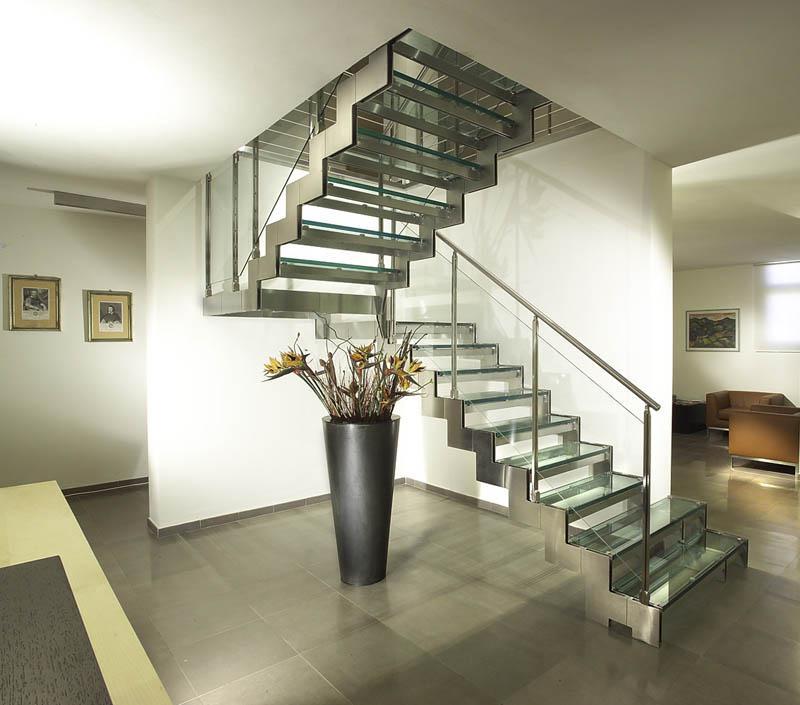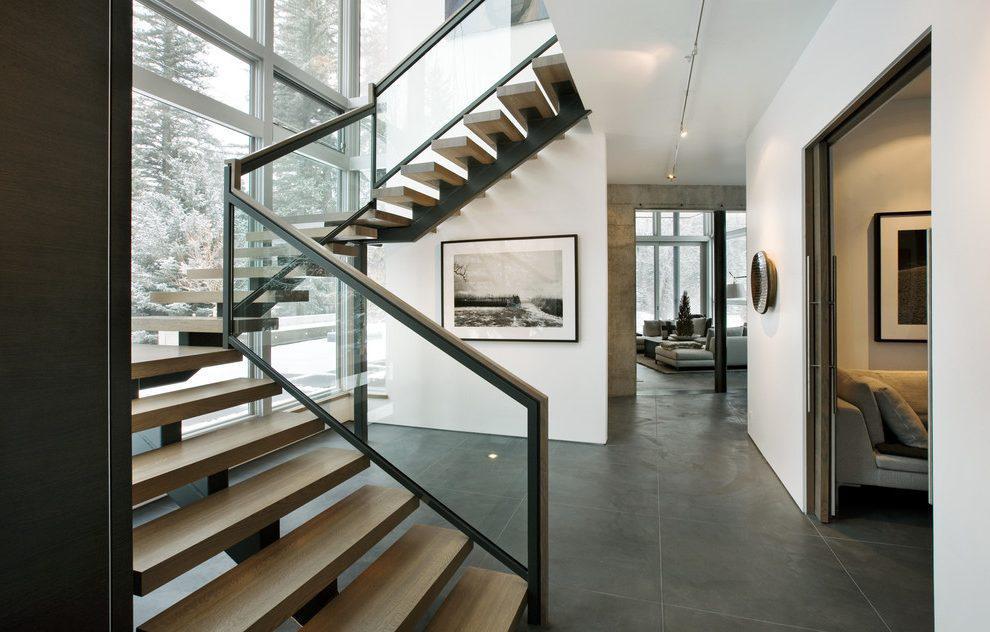The first image is the image on the left, the second image is the image on the right. For the images displayed, is the sentence "The right image features a staircase with a curved wood rail, and the left image features a staircase with a right-angle turn." factually correct? Answer yes or no. No. The first image is the image on the left, the second image is the image on the right. Assess this claim about the two images: "The stairs in the image on the right curve near a large open window.". Correct or not? Answer yes or no. Yes. 